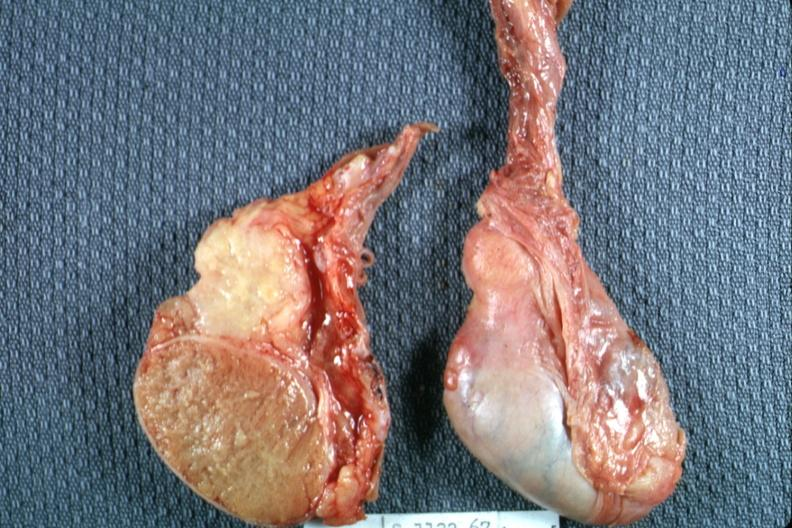s epididymis present?
Answer the question using a single word or phrase. Yes 